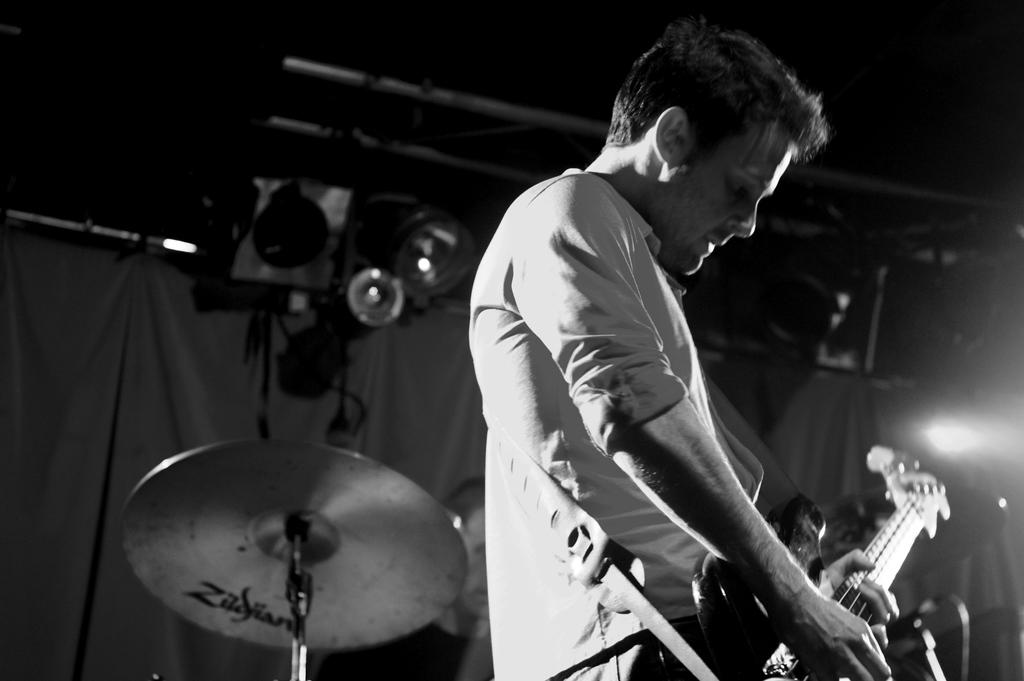What is the main subject of the image? The main subject of the image is a man. What is the man doing in the image? The man is standing and playing a guitar. Are there any other musical instruments visible in the image? Yes, there are drums visible in the image. How many cobwebs can be seen in the image? There are no cobwebs present in the image. What type of family gathering is depicted in the image? There is no family gathering depicted in the image; it features a man playing a guitar and drums. 